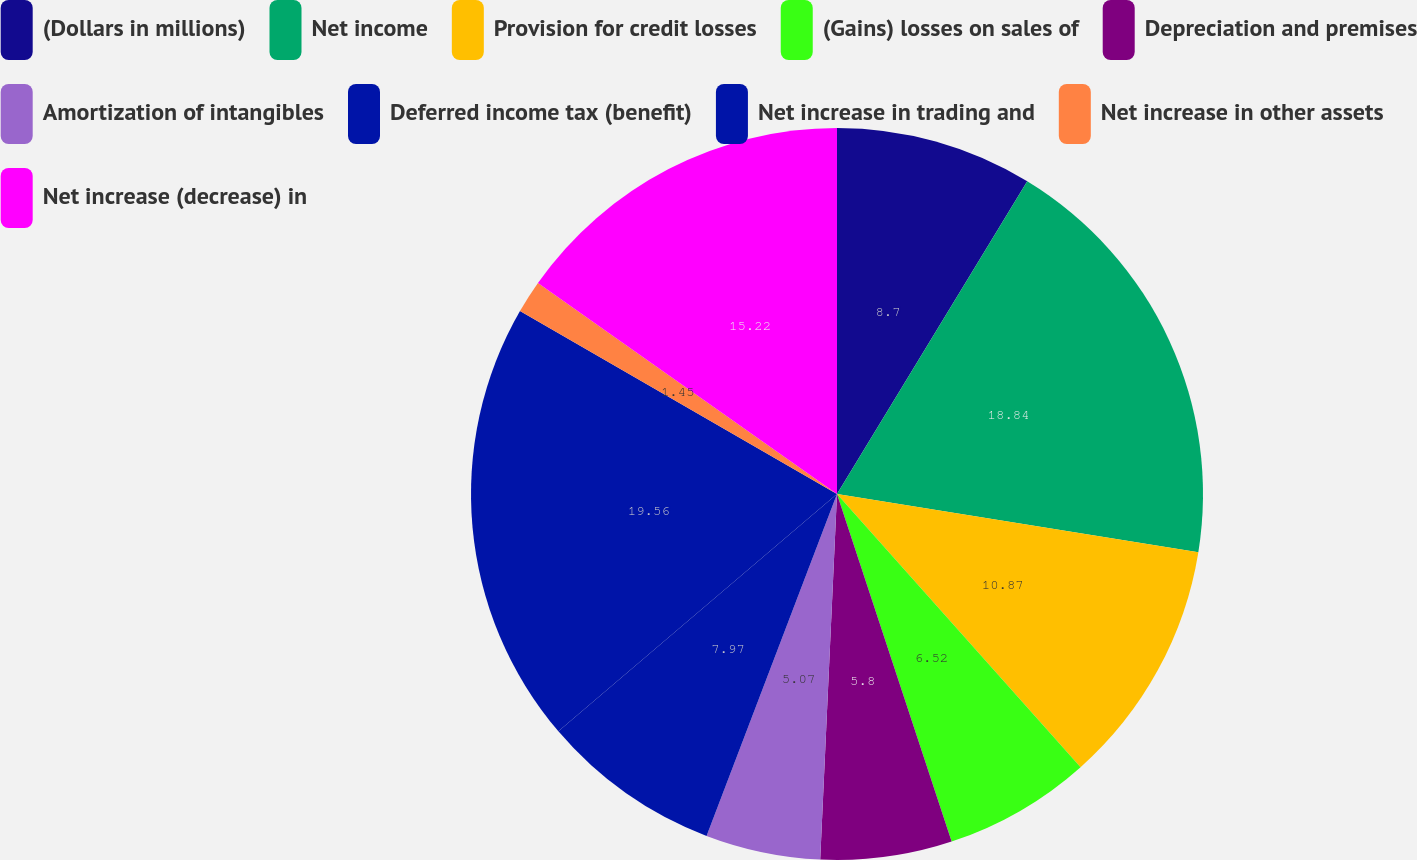Convert chart to OTSL. <chart><loc_0><loc_0><loc_500><loc_500><pie_chart><fcel>(Dollars in millions)<fcel>Net income<fcel>Provision for credit losses<fcel>(Gains) losses on sales of<fcel>Depreciation and premises<fcel>Amortization of intangibles<fcel>Deferred income tax (benefit)<fcel>Net increase in trading and<fcel>Net increase in other assets<fcel>Net increase (decrease) in<nl><fcel>8.7%<fcel>18.84%<fcel>10.87%<fcel>6.52%<fcel>5.8%<fcel>5.07%<fcel>7.97%<fcel>19.56%<fcel>1.45%<fcel>15.22%<nl></chart> 